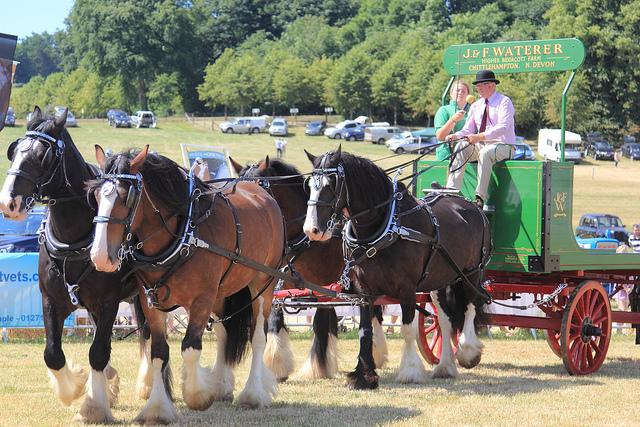What is the guy wearing a black hat doing? driving 